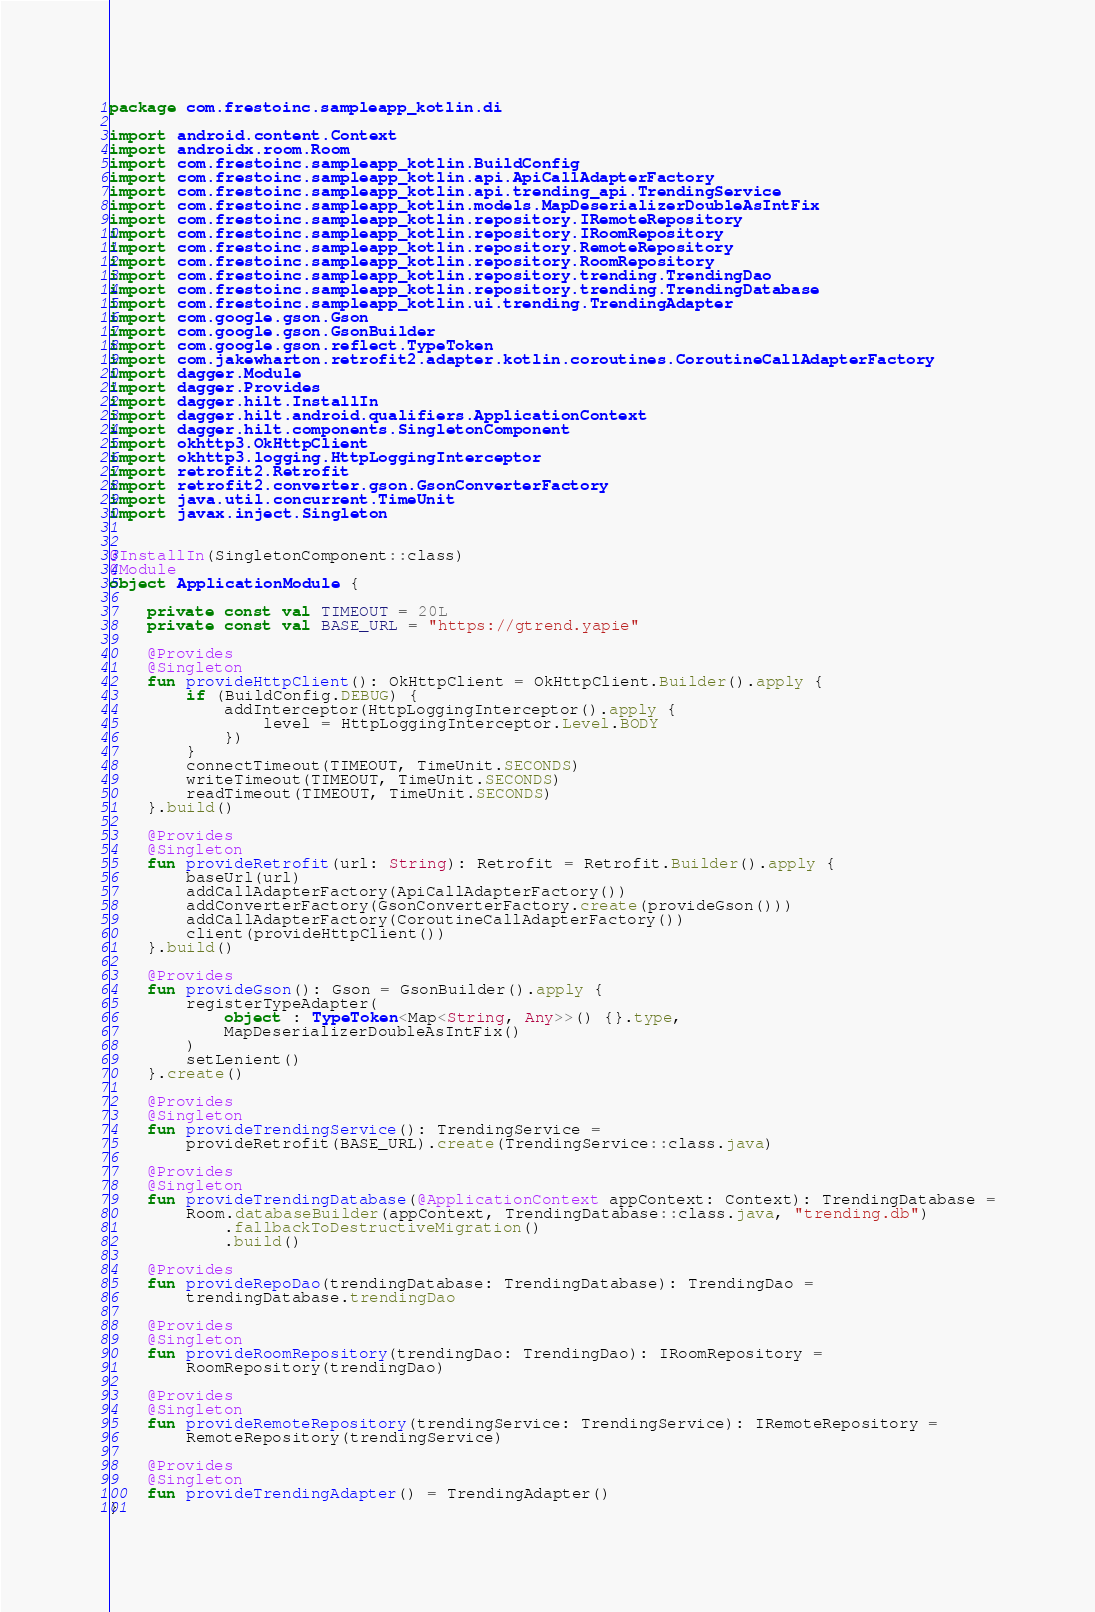Convert code to text. <code><loc_0><loc_0><loc_500><loc_500><_Kotlin_>package com.frestoinc.sampleapp_kotlin.di

import android.content.Context
import androidx.room.Room
import com.frestoinc.sampleapp_kotlin.BuildConfig
import com.frestoinc.sampleapp_kotlin.api.ApiCallAdapterFactory
import com.frestoinc.sampleapp_kotlin.api.trending_api.TrendingService
import com.frestoinc.sampleapp_kotlin.models.MapDeserializerDoubleAsIntFix
import com.frestoinc.sampleapp_kotlin.repository.IRemoteRepository
import com.frestoinc.sampleapp_kotlin.repository.IRoomRepository
import com.frestoinc.sampleapp_kotlin.repository.RemoteRepository
import com.frestoinc.sampleapp_kotlin.repository.RoomRepository
import com.frestoinc.sampleapp_kotlin.repository.trending.TrendingDao
import com.frestoinc.sampleapp_kotlin.repository.trending.TrendingDatabase
import com.frestoinc.sampleapp_kotlin.ui.trending.TrendingAdapter
import com.google.gson.Gson
import com.google.gson.GsonBuilder
import com.google.gson.reflect.TypeToken
import com.jakewharton.retrofit2.adapter.kotlin.coroutines.CoroutineCallAdapterFactory
import dagger.Module
import dagger.Provides
import dagger.hilt.InstallIn
import dagger.hilt.android.qualifiers.ApplicationContext
import dagger.hilt.components.SingletonComponent
import okhttp3.OkHttpClient
import okhttp3.logging.HttpLoggingInterceptor
import retrofit2.Retrofit
import retrofit2.converter.gson.GsonConverterFactory
import java.util.concurrent.TimeUnit
import javax.inject.Singleton


@InstallIn(SingletonComponent::class)
@Module
object ApplicationModule {

    private const val TIMEOUT = 20L
    private const val BASE_URL = "https://gtrend.yapie"

    @Provides
    @Singleton
    fun provideHttpClient(): OkHttpClient = OkHttpClient.Builder().apply {
        if (BuildConfig.DEBUG) {
            addInterceptor(HttpLoggingInterceptor().apply {
                level = HttpLoggingInterceptor.Level.BODY
            })
        }
        connectTimeout(TIMEOUT, TimeUnit.SECONDS)
        writeTimeout(TIMEOUT, TimeUnit.SECONDS)
        readTimeout(TIMEOUT, TimeUnit.SECONDS)
    }.build()

    @Provides
    @Singleton
    fun provideRetrofit(url: String): Retrofit = Retrofit.Builder().apply {
        baseUrl(url)
        addCallAdapterFactory(ApiCallAdapterFactory())
        addConverterFactory(GsonConverterFactory.create(provideGson()))
        addCallAdapterFactory(CoroutineCallAdapterFactory())
        client(provideHttpClient())
    }.build()

    @Provides
    fun provideGson(): Gson = GsonBuilder().apply {
        registerTypeAdapter(
            object : TypeToken<Map<String, Any>>() {}.type,
            MapDeserializerDoubleAsIntFix()
        )
        setLenient()
    }.create()

    @Provides
    @Singleton
    fun provideTrendingService(): TrendingService =
        provideRetrofit(BASE_URL).create(TrendingService::class.java)

    @Provides
    @Singleton
    fun provideTrendingDatabase(@ApplicationContext appContext: Context): TrendingDatabase =
        Room.databaseBuilder(appContext, TrendingDatabase::class.java, "trending.db")
            .fallbackToDestructiveMigration()
            .build()

    @Provides
    fun provideRepoDao(trendingDatabase: TrendingDatabase): TrendingDao =
        trendingDatabase.trendingDao

    @Provides
    @Singleton
    fun provideRoomRepository(trendingDao: TrendingDao): IRoomRepository =
        RoomRepository(trendingDao)

    @Provides
    @Singleton
    fun provideRemoteRepository(trendingService: TrendingService): IRemoteRepository =
        RemoteRepository(trendingService)

    @Provides
    @Singleton
    fun provideTrendingAdapter() = TrendingAdapter()
}
</code> 